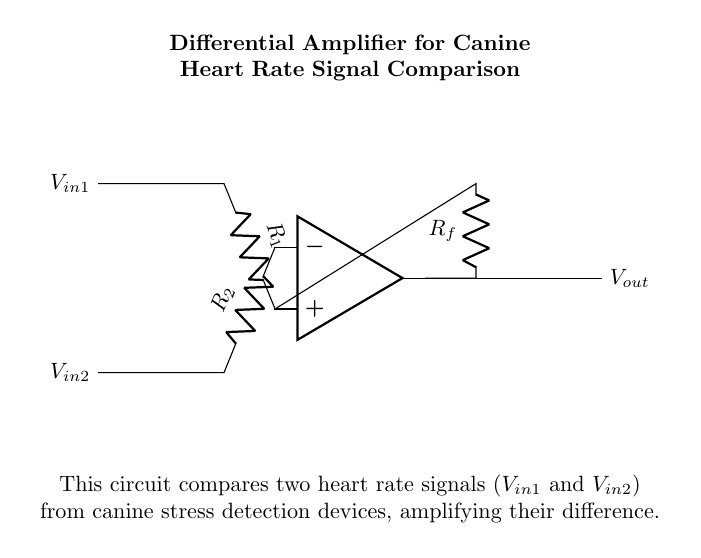What type of amplifier is this? This circuit is a differential amplifier, which is specifically designed to amplify the difference between two input voltage signals. The op amp in the diagram is used to compare the heart rate signals.
Answer: Differential amplifier What do the input signals represent? The input signals, labeled as V-in1 and V-in2, represent two different heart rate signals being compared for detecting canine stress. These signals are necessary for the analysis of heart rates in dogs.
Answer: Heart rate signals What is the function of the feedback resistor? The feedback resistor, labeled as R-f, controls the gain of the differential amplifier. It helps determine how much of the output signal is fed back to the input, affecting the amplification factor of the circuit.
Answer: Gain control What are the two input resistors in the circuit? The two input resistors are R-1 and R-2. Each resistor is connected to one of the input signals (V-in1 and V-in2) and is essential for biasing the operation of the differential amplifier.
Answer: R-1 and R-2 What is the output of this circuit? The output of this circuit, labeled as V-out, is the amplified difference between the two input heart rate signals. This output can be used for further processing or monitoring.
Answer: V-out How does the differential amplifier process the signals? The differential amplifier resolves the signals by subtracting one input (V-in2) from the other input (V-in1), effectively amplifying only the difference. This makes it sensitive to changes between the two signals, providing a clear measurement of stress levels in canines.
Answer: Amplifies difference 